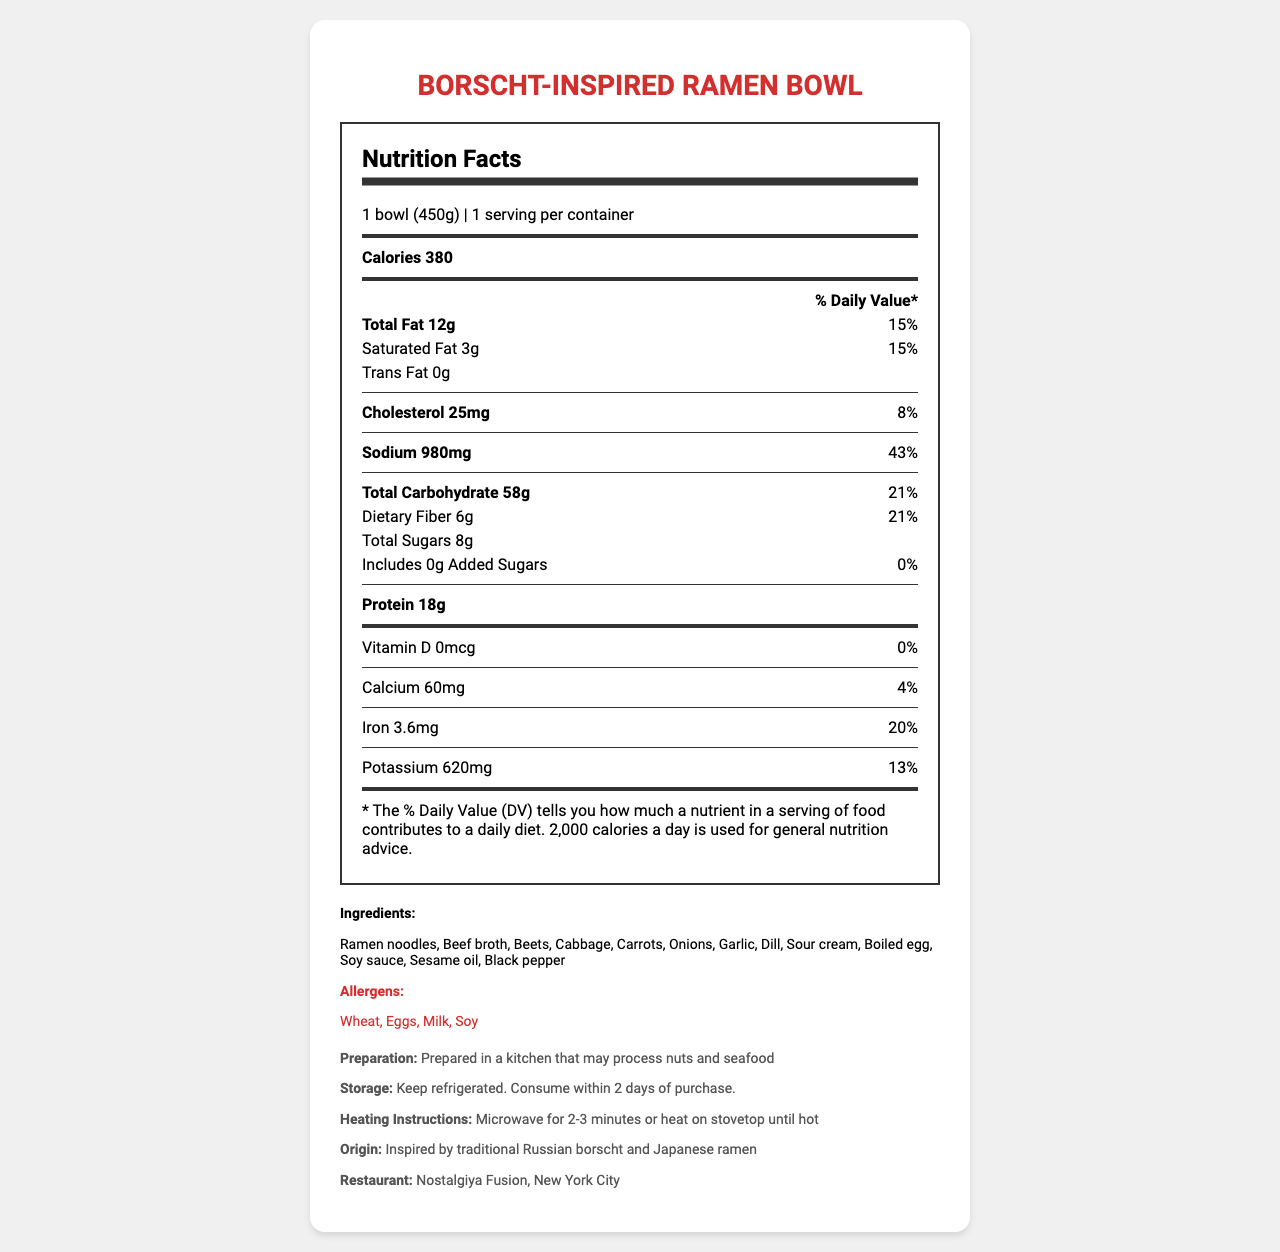what is the serving size for the Borscht-Inspired Ramen Bowl? The serving size is explicitly mentioned at the beginning of the nutrition facts section as "1 bowl (450g)".
Answer: 1 bowl (450g) how many grams of total fat are in one serving of the dish? The total fat content is listed as "Total Fat 12g" in the nutrition facts section.
Answer: 12g what percentage of the daily value for sodium does one serving provide? The sodium content is listed as "Sodium 980mg" with a daily value of 43%, clearly marking the percentage.
Answer: 43% how much protein is in the dish? The amount of protein is listed as "Protein 18g" in the nutrition facts section.
Answer: 18g which allergens are present in the Borscht-Inspired Ramen Bowl? The allergens are explicitly mentioned in the allergens section.
Answer: Wheat, Eggs, Milk, Soy how much cholesterol is in one serving? A. 25mg B. 50mg C. 75mg D. 100mg The nutrition facts section lists "Cholesterol 25mg".
Answer: A. 25mg how many servings per container are included? A. 1 B. 2 C. 3 D. 4 The servings per container are listed as "1 serving per container" in the nutrition facts section.
Answer: A. 1 does the dish contain any trans fat? The trans fat content is listed as "0g" in the nutrition facts section.
Answer: No is the dish high in dietary fiber based on the daily value percentage? The dietary fiber content is 6g with a daily value of 21%, which is considered high.
Answer: Yes summarize the main information in the Nutrition Facts label of the Borscht-Inspired Ramen Bowl. The document details the essential nutritional components, preparation, storage, and origin information for the Borscht-Inspired Ramen Bowl, helping consumers understand its nutritional content and usage.
Answer: The Borscht-Inspired Ramen Bowl contains 380 calories per serving, with significant amounts of total fat, sodium, and carbohydrates. It provides dietary fiber, protein, and various vitamins and minerals. It includes multiple allergens and is sourced from a fusion of Russian and Japanese cuisines. Preparation instructions and storage guidelines are also provided. what is the preparation instruction mentioned for the dish? The preparation instruction mentions that it is prepared in a kitchen that may process nuts and seafood.
Answer: Prepared in a kitchen that may process nuts and seafood where can the Borscht-Inspired Ramen Bowl be sourced from? The restaurant information is mentioned in the additional info section.
Answer: Nostalgiya Fusion, New York City how many grams of added sugars are included in the dish? The amount of added sugars is explicitly listed as "Includes 0g Added Sugars".
Answer: 0g is there any Vitamin D in the dish? The Vitamin D content is listed as "0mcg" with a daily value of 0%.
Answer: No how long should you heat the dish in a microwave? The heating instructions mention "Microwave for 2-3 minutes or heat on stovetop until hot."
Answer: 2-3 minutes are there any dietary restrictions mentioned for potassium in the dish? The document does not provide any specific dietary restrictions or recommendations regarding potassium content.
Answer: Not enough information is the container size mentioned in the nutrition facts label large? The serving size is "1 bowl (450g)," which does not indicate a large container size.
Answer: No how much calcium does one serving of the Borscht-Inspired Ramen Bowl contain? The calcium content is listed explicitly in the nutrition facts section as "Calcium 60mg".
Answer: 60mg 